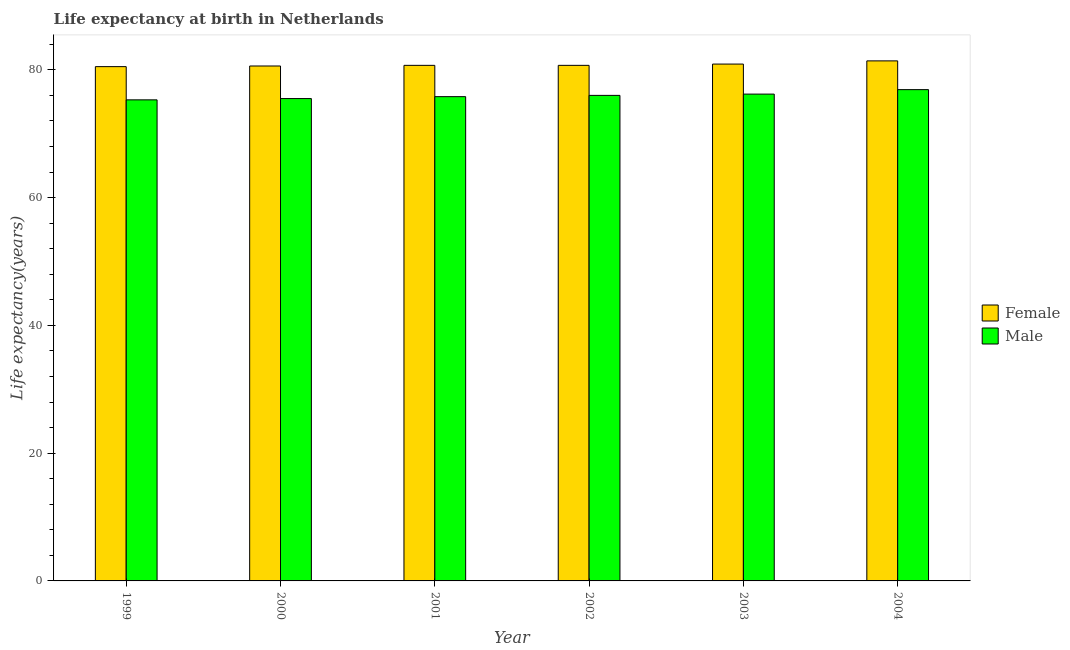How many different coloured bars are there?
Offer a very short reply. 2. Are the number of bars per tick equal to the number of legend labels?
Provide a succinct answer. Yes. Are the number of bars on each tick of the X-axis equal?
Your answer should be very brief. Yes. How many bars are there on the 2nd tick from the left?
Offer a very short reply. 2. What is the label of the 6th group of bars from the left?
Your response must be concise. 2004. In how many cases, is the number of bars for a given year not equal to the number of legend labels?
Your answer should be compact. 0. What is the life expectancy(male) in 1999?
Ensure brevity in your answer.  75.3. Across all years, what is the maximum life expectancy(male)?
Your answer should be compact. 76.9. Across all years, what is the minimum life expectancy(female)?
Make the answer very short. 80.5. In which year was the life expectancy(male) maximum?
Your answer should be compact. 2004. What is the total life expectancy(female) in the graph?
Offer a terse response. 484.8. What is the difference between the life expectancy(female) in 1999 and that in 2001?
Make the answer very short. -0.2. What is the difference between the life expectancy(male) in 2003 and the life expectancy(female) in 2002?
Ensure brevity in your answer.  0.2. What is the average life expectancy(female) per year?
Make the answer very short. 80.8. In how many years, is the life expectancy(female) greater than 32 years?
Offer a terse response. 6. What is the ratio of the life expectancy(male) in 2001 to that in 2004?
Your response must be concise. 0.99. Is the difference between the life expectancy(female) in 1999 and 2002 greater than the difference between the life expectancy(male) in 1999 and 2002?
Your answer should be compact. No. What is the difference between the highest and the lowest life expectancy(female)?
Offer a very short reply. 0.9. In how many years, is the life expectancy(female) greater than the average life expectancy(female) taken over all years?
Ensure brevity in your answer.  2. Is the sum of the life expectancy(male) in 2002 and 2003 greater than the maximum life expectancy(female) across all years?
Give a very brief answer. Yes. What does the 2nd bar from the left in 2000 represents?
Offer a very short reply. Male. What does the 1st bar from the right in 2004 represents?
Make the answer very short. Male. How many bars are there?
Offer a terse response. 12. Are all the bars in the graph horizontal?
Offer a terse response. No. What is the difference between two consecutive major ticks on the Y-axis?
Offer a terse response. 20. Are the values on the major ticks of Y-axis written in scientific E-notation?
Offer a terse response. No. Does the graph contain any zero values?
Give a very brief answer. No. Does the graph contain grids?
Provide a short and direct response. No. Where does the legend appear in the graph?
Make the answer very short. Center right. How are the legend labels stacked?
Offer a terse response. Vertical. What is the title of the graph?
Provide a succinct answer. Life expectancy at birth in Netherlands. Does "Registered firms" appear as one of the legend labels in the graph?
Provide a succinct answer. No. What is the label or title of the X-axis?
Offer a very short reply. Year. What is the label or title of the Y-axis?
Offer a terse response. Life expectancy(years). What is the Life expectancy(years) in Female in 1999?
Give a very brief answer. 80.5. What is the Life expectancy(years) of Male in 1999?
Ensure brevity in your answer.  75.3. What is the Life expectancy(years) of Female in 2000?
Your answer should be compact. 80.6. What is the Life expectancy(years) of Male in 2000?
Ensure brevity in your answer.  75.5. What is the Life expectancy(years) in Female in 2001?
Your answer should be compact. 80.7. What is the Life expectancy(years) of Male in 2001?
Keep it short and to the point. 75.8. What is the Life expectancy(years) in Female in 2002?
Your answer should be very brief. 80.7. What is the Life expectancy(years) in Male in 2002?
Make the answer very short. 76. What is the Life expectancy(years) in Female in 2003?
Offer a very short reply. 80.9. What is the Life expectancy(years) in Male in 2003?
Ensure brevity in your answer.  76.2. What is the Life expectancy(years) in Female in 2004?
Your answer should be compact. 81.4. What is the Life expectancy(years) of Male in 2004?
Make the answer very short. 76.9. Across all years, what is the maximum Life expectancy(years) of Female?
Your response must be concise. 81.4. Across all years, what is the maximum Life expectancy(years) in Male?
Give a very brief answer. 76.9. Across all years, what is the minimum Life expectancy(years) of Female?
Your answer should be very brief. 80.5. Across all years, what is the minimum Life expectancy(years) of Male?
Provide a short and direct response. 75.3. What is the total Life expectancy(years) in Female in the graph?
Ensure brevity in your answer.  484.8. What is the total Life expectancy(years) in Male in the graph?
Ensure brevity in your answer.  455.7. What is the difference between the Life expectancy(years) in Female in 1999 and that in 2000?
Give a very brief answer. -0.1. What is the difference between the Life expectancy(years) in Male in 1999 and that in 2000?
Make the answer very short. -0.2. What is the difference between the Life expectancy(years) of Female in 1999 and that in 2001?
Your response must be concise. -0.2. What is the difference between the Life expectancy(years) in Male in 1999 and that in 2001?
Offer a very short reply. -0.5. What is the difference between the Life expectancy(years) of Female in 1999 and that in 2003?
Ensure brevity in your answer.  -0.4. What is the difference between the Life expectancy(years) of Male in 1999 and that in 2003?
Give a very brief answer. -0.9. What is the difference between the Life expectancy(years) in Female in 1999 and that in 2004?
Your answer should be compact. -0.9. What is the difference between the Life expectancy(years) in Female in 2000 and that in 2001?
Make the answer very short. -0.1. What is the difference between the Life expectancy(years) of Male in 2000 and that in 2001?
Make the answer very short. -0.3. What is the difference between the Life expectancy(years) in Female in 2000 and that in 2002?
Provide a succinct answer. -0.1. What is the difference between the Life expectancy(years) in Male in 2000 and that in 2002?
Make the answer very short. -0.5. What is the difference between the Life expectancy(years) of Male in 2000 and that in 2003?
Provide a short and direct response. -0.7. What is the difference between the Life expectancy(years) of Male in 2000 and that in 2004?
Provide a short and direct response. -1.4. What is the difference between the Life expectancy(years) of Female in 2001 and that in 2002?
Offer a terse response. 0. What is the difference between the Life expectancy(years) in Male in 2001 and that in 2002?
Give a very brief answer. -0.2. What is the difference between the Life expectancy(years) in Female in 2001 and that in 2003?
Offer a terse response. -0.2. What is the difference between the Life expectancy(years) in Male in 2001 and that in 2003?
Give a very brief answer. -0.4. What is the difference between the Life expectancy(years) in Male in 2001 and that in 2004?
Your answer should be compact. -1.1. What is the difference between the Life expectancy(years) of Female in 2002 and that in 2004?
Your answer should be very brief. -0.7. What is the difference between the Life expectancy(years) of Female in 1999 and the Life expectancy(years) of Male in 2001?
Ensure brevity in your answer.  4.7. What is the difference between the Life expectancy(years) of Female in 1999 and the Life expectancy(years) of Male in 2002?
Make the answer very short. 4.5. What is the difference between the Life expectancy(years) in Female in 1999 and the Life expectancy(years) in Male in 2004?
Make the answer very short. 3.6. What is the difference between the Life expectancy(years) of Female in 2000 and the Life expectancy(years) of Male in 2003?
Offer a terse response. 4.4. What is the difference between the Life expectancy(years) of Female in 2000 and the Life expectancy(years) of Male in 2004?
Provide a succinct answer. 3.7. What is the difference between the Life expectancy(years) of Female in 2001 and the Life expectancy(years) of Male in 2004?
Your response must be concise. 3.8. What is the difference between the Life expectancy(years) in Female in 2003 and the Life expectancy(years) in Male in 2004?
Provide a short and direct response. 4. What is the average Life expectancy(years) of Female per year?
Your answer should be compact. 80.8. What is the average Life expectancy(years) in Male per year?
Your answer should be very brief. 75.95. In the year 1999, what is the difference between the Life expectancy(years) of Female and Life expectancy(years) of Male?
Give a very brief answer. 5.2. In the year 2000, what is the difference between the Life expectancy(years) in Female and Life expectancy(years) in Male?
Keep it short and to the point. 5.1. In the year 2001, what is the difference between the Life expectancy(years) in Female and Life expectancy(years) in Male?
Make the answer very short. 4.9. In the year 2002, what is the difference between the Life expectancy(years) in Female and Life expectancy(years) in Male?
Keep it short and to the point. 4.7. What is the ratio of the Life expectancy(years) in Female in 1999 to that in 2000?
Your response must be concise. 1. What is the ratio of the Life expectancy(years) in Male in 1999 to that in 2000?
Your response must be concise. 1. What is the ratio of the Life expectancy(years) of Male in 1999 to that in 2001?
Ensure brevity in your answer.  0.99. What is the ratio of the Life expectancy(years) of Male in 1999 to that in 2003?
Your answer should be very brief. 0.99. What is the ratio of the Life expectancy(years) of Female in 1999 to that in 2004?
Offer a very short reply. 0.99. What is the ratio of the Life expectancy(years) of Male in 1999 to that in 2004?
Ensure brevity in your answer.  0.98. What is the ratio of the Life expectancy(years) of Female in 2000 to that in 2003?
Keep it short and to the point. 1. What is the ratio of the Life expectancy(years) of Male in 2000 to that in 2003?
Your response must be concise. 0.99. What is the ratio of the Life expectancy(years) of Female in 2000 to that in 2004?
Your answer should be compact. 0.99. What is the ratio of the Life expectancy(years) in Male in 2000 to that in 2004?
Your answer should be compact. 0.98. What is the ratio of the Life expectancy(years) in Female in 2001 to that in 2002?
Give a very brief answer. 1. What is the ratio of the Life expectancy(years) of Female in 2001 to that in 2004?
Give a very brief answer. 0.99. What is the ratio of the Life expectancy(years) of Male in 2001 to that in 2004?
Make the answer very short. 0.99. What is the ratio of the Life expectancy(years) in Female in 2002 to that in 2004?
Ensure brevity in your answer.  0.99. What is the ratio of the Life expectancy(years) in Male in 2002 to that in 2004?
Provide a succinct answer. 0.99. What is the ratio of the Life expectancy(years) of Female in 2003 to that in 2004?
Ensure brevity in your answer.  0.99. What is the ratio of the Life expectancy(years) in Male in 2003 to that in 2004?
Your response must be concise. 0.99. What is the difference between the highest and the lowest Life expectancy(years) in Female?
Make the answer very short. 0.9. What is the difference between the highest and the lowest Life expectancy(years) in Male?
Your response must be concise. 1.6. 